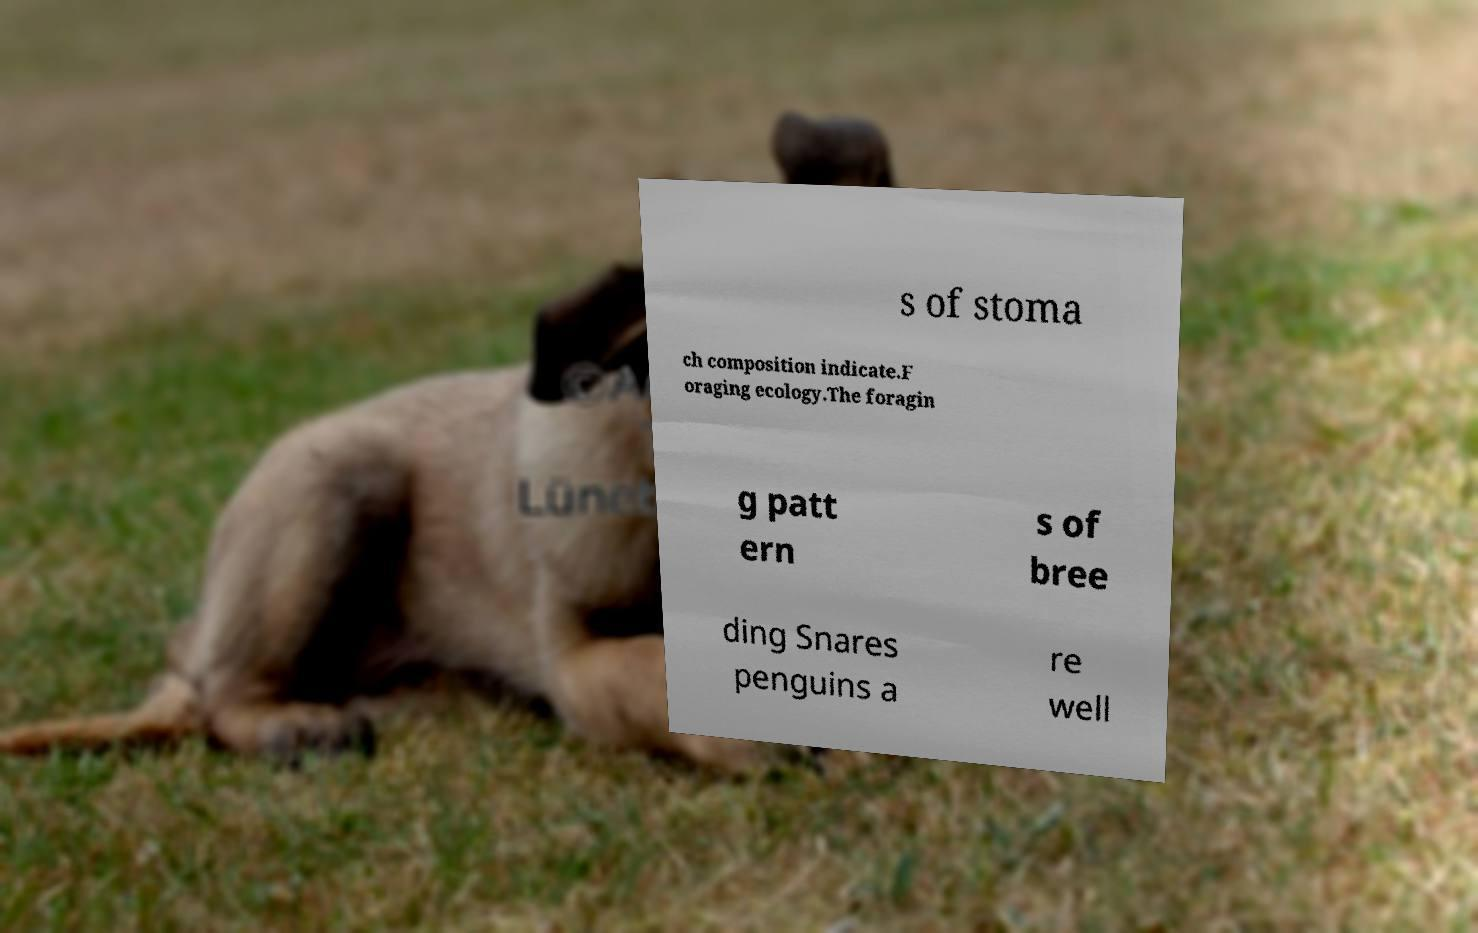For documentation purposes, I need the text within this image transcribed. Could you provide that? s of stoma ch composition indicate.F oraging ecology.The foragin g patt ern s of bree ding Snares penguins a re well 